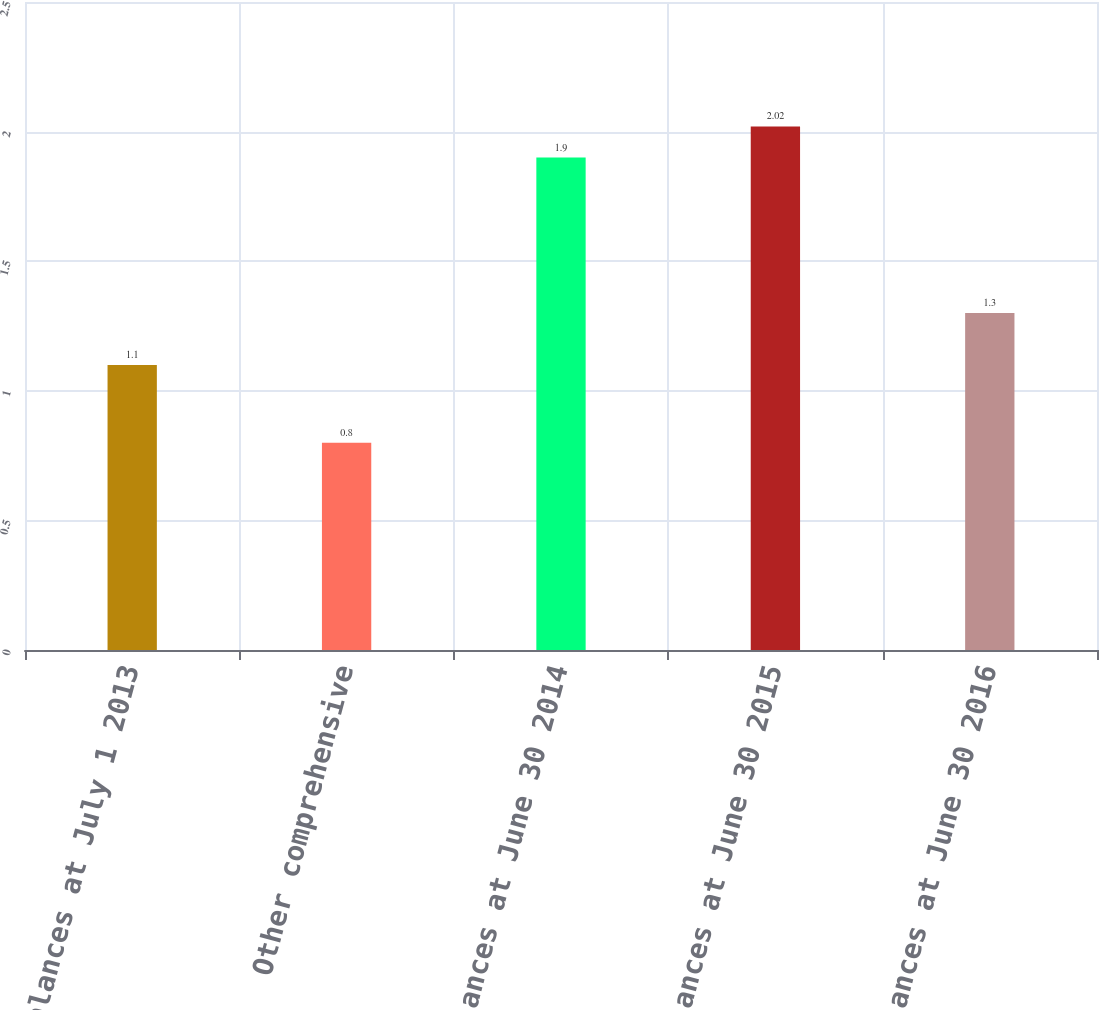Convert chart. <chart><loc_0><loc_0><loc_500><loc_500><bar_chart><fcel>Balances at July 1 2013<fcel>Other comprehensive<fcel>Balances at June 30 2014<fcel>Balances at June 30 2015<fcel>Balances at June 30 2016<nl><fcel>1.1<fcel>0.8<fcel>1.9<fcel>2.02<fcel>1.3<nl></chart> 